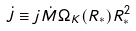<formula> <loc_0><loc_0><loc_500><loc_500>\dot { J } \equiv j \dot { M } \Omega _ { K } ( R _ { * } ) R _ { * } ^ { 2 }</formula> 